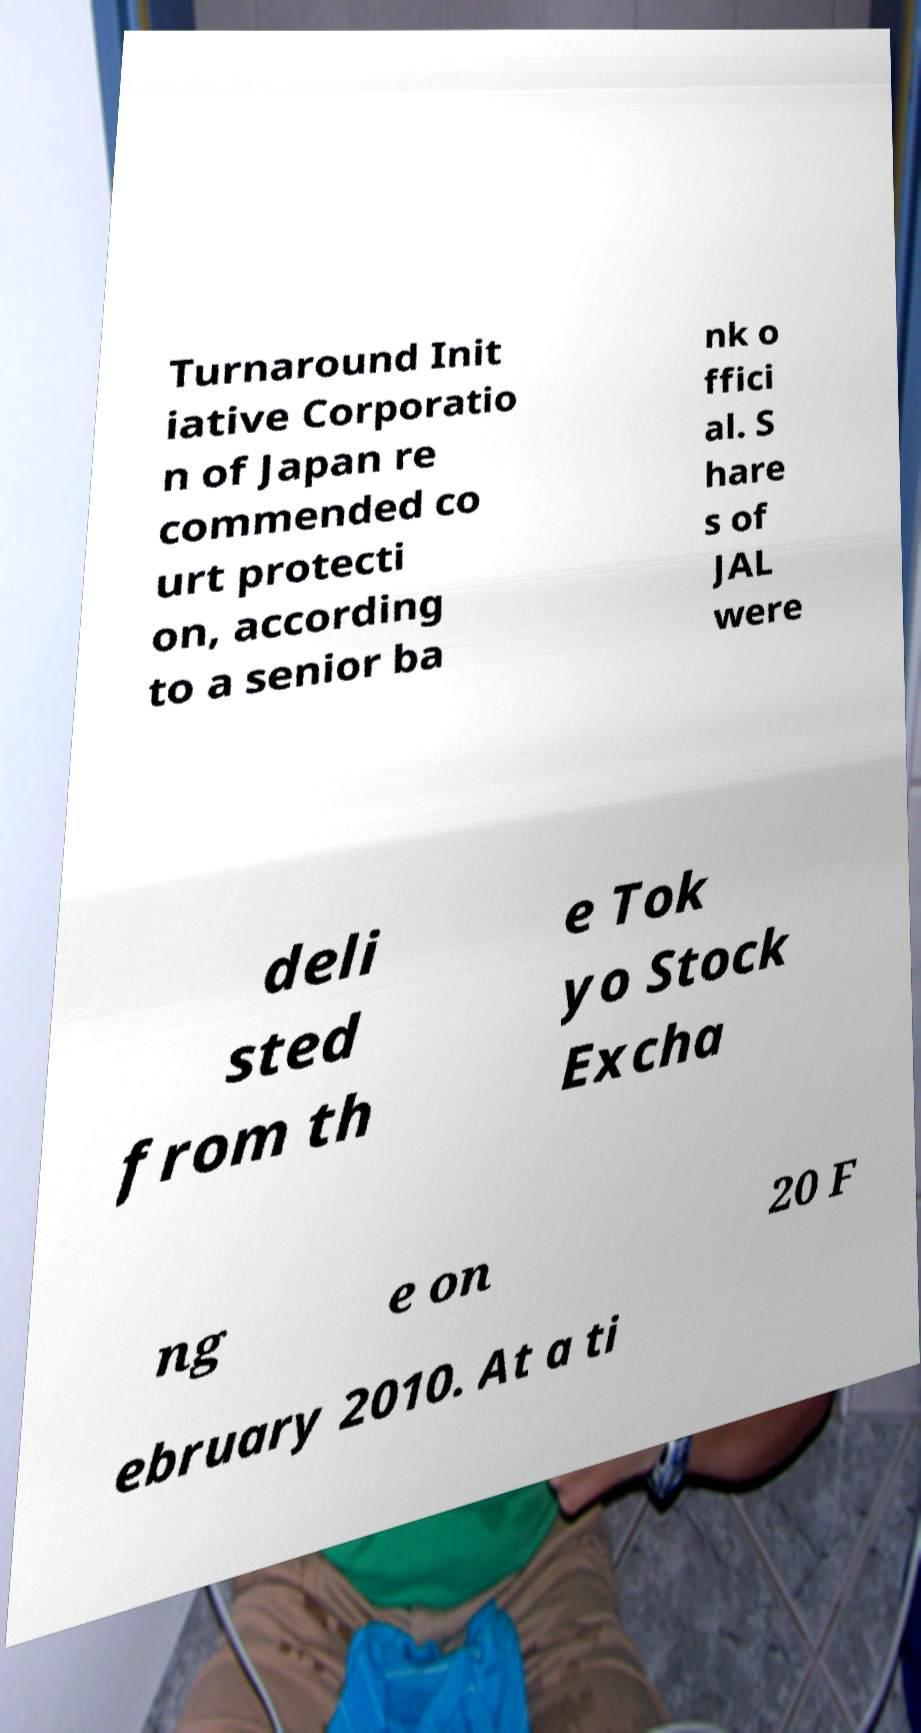Could you extract and type out the text from this image? Turnaround Init iative Corporatio n of Japan re commended co urt protecti on, according to a senior ba nk o ffici al. S hare s of JAL were deli sted from th e Tok yo Stock Excha ng e on 20 F ebruary 2010. At a ti 